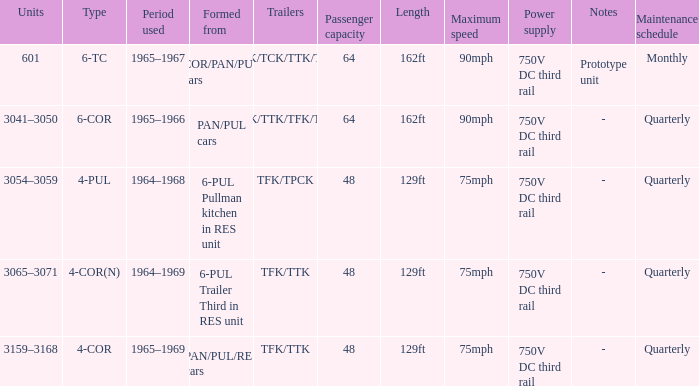Name the trailers for formed from pan/pul/res cars TFK/TTK. 